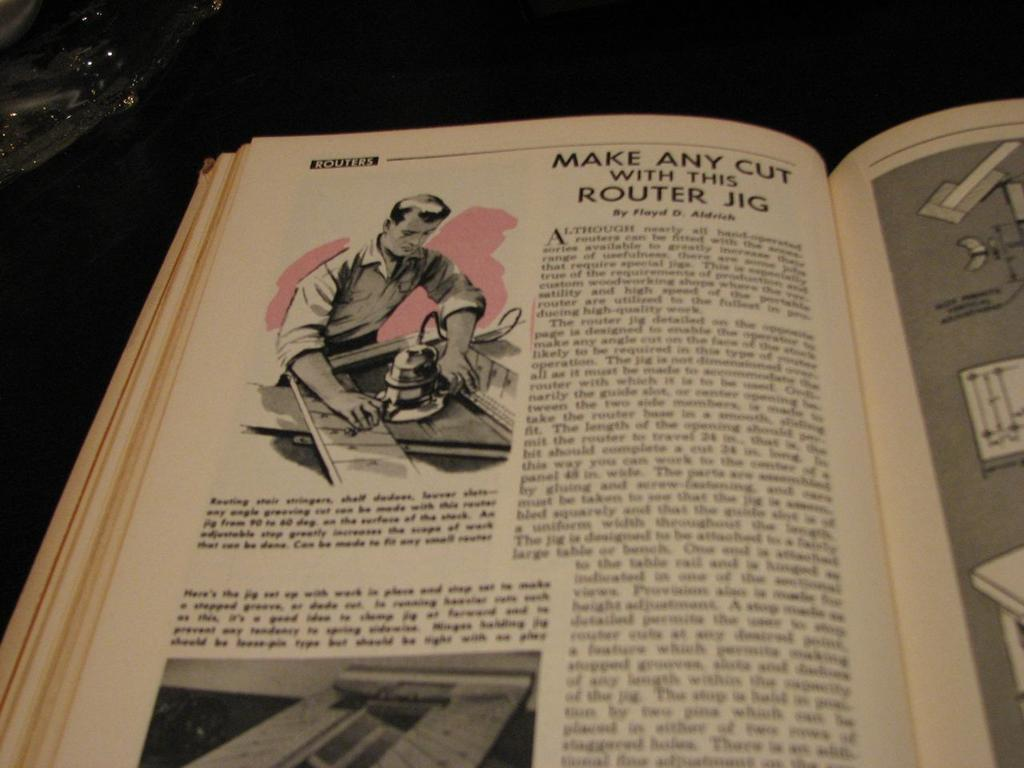What is the main subject of the image? There is a book in the center of the image. What can be found on the book? There is text written on the book and images on the book. What type of fire can be seen coming from the book in the image? There is no fire present in the image; it is a book with text and images. What kind of joke is written on the book in the image? There is no joke written on the book in the image; it contains text and images on a subject that is not specified. 